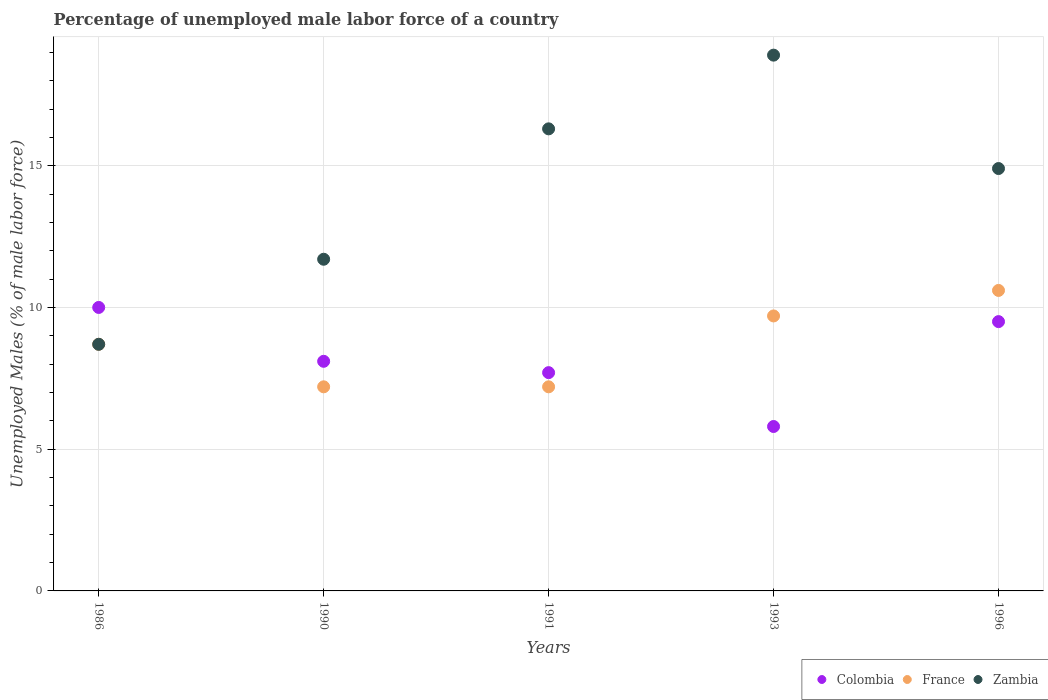Is the number of dotlines equal to the number of legend labels?
Your answer should be very brief. Yes. What is the percentage of unemployed male labor force in Zambia in 1991?
Make the answer very short. 16.3. Across all years, what is the maximum percentage of unemployed male labor force in France?
Give a very brief answer. 10.6. Across all years, what is the minimum percentage of unemployed male labor force in Colombia?
Your response must be concise. 5.8. In which year was the percentage of unemployed male labor force in Colombia maximum?
Keep it short and to the point. 1986. In which year was the percentage of unemployed male labor force in Zambia minimum?
Your answer should be very brief. 1986. What is the total percentage of unemployed male labor force in France in the graph?
Provide a short and direct response. 43.4. What is the difference between the percentage of unemployed male labor force in Zambia in 1990 and that in 1996?
Your answer should be compact. -3.2. What is the difference between the percentage of unemployed male labor force in Colombia in 1993 and the percentage of unemployed male labor force in Zambia in 1990?
Offer a terse response. -5.9. What is the average percentage of unemployed male labor force in Zambia per year?
Offer a terse response. 14.1. In the year 1993, what is the difference between the percentage of unemployed male labor force in France and percentage of unemployed male labor force in Zambia?
Your response must be concise. -9.2. What is the ratio of the percentage of unemployed male labor force in Colombia in 1993 to that in 1996?
Provide a succinct answer. 0.61. Is the percentage of unemployed male labor force in Zambia in 1986 less than that in 1990?
Offer a terse response. Yes. Is the difference between the percentage of unemployed male labor force in France in 1986 and 1991 greater than the difference between the percentage of unemployed male labor force in Zambia in 1986 and 1991?
Ensure brevity in your answer.  Yes. What is the difference between the highest and the second highest percentage of unemployed male labor force in Zambia?
Ensure brevity in your answer.  2.6. What is the difference between the highest and the lowest percentage of unemployed male labor force in Colombia?
Your answer should be very brief. 4.2. In how many years, is the percentage of unemployed male labor force in France greater than the average percentage of unemployed male labor force in France taken over all years?
Provide a short and direct response. 3. Is the sum of the percentage of unemployed male labor force in Colombia in 1986 and 1993 greater than the maximum percentage of unemployed male labor force in France across all years?
Your answer should be compact. Yes. Is the percentage of unemployed male labor force in France strictly greater than the percentage of unemployed male labor force in Zambia over the years?
Make the answer very short. No. Is the percentage of unemployed male labor force in France strictly less than the percentage of unemployed male labor force in Colombia over the years?
Make the answer very short. No. How many dotlines are there?
Give a very brief answer. 3. Are the values on the major ticks of Y-axis written in scientific E-notation?
Make the answer very short. No. Does the graph contain any zero values?
Your response must be concise. No. Where does the legend appear in the graph?
Provide a short and direct response. Bottom right. How are the legend labels stacked?
Provide a short and direct response. Horizontal. What is the title of the graph?
Give a very brief answer. Percentage of unemployed male labor force of a country. What is the label or title of the Y-axis?
Provide a short and direct response. Unemployed Males (% of male labor force). What is the Unemployed Males (% of male labor force) in Colombia in 1986?
Your answer should be compact. 10. What is the Unemployed Males (% of male labor force) in France in 1986?
Offer a very short reply. 8.7. What is the Unemployed Males (% of male labor force) in Zambia in 1986?
Offer a very short reply. 8.7. What is the Unemployed Males (% of male labor force) in Colombia in 1990?
Your answer should be compact. 8.1. What is the Unemployed Males (% of male labor force) in France in 1990?
Your answer should be compact. 7.2. What is the Unemployed Males (% of male labor force) in Zambia in 1990?
Your answer should be very brief. 11.7. What is the Unemployed Males (% of male labor force) of Colombia in 1991?
Ensure brevity in your answer.  7.7. What is the Unemployed Males (% of male labor force) of France in 1991?
Your answer should be very brief. 7.2. What is the Unemployed Males (% of male labor force) of Zambia in 1991?
Your answer should be compact. 16.3. What is the Unemployed Males (% of male labor force) in Colombia in 1993?
Keep it short and to the point. 5.8. What is the Unemployed Males (% of male labor force) of France in 1993?
Your response must be concise. 9.7. What is the Unemployed Males (% of male labor force) in Zambia in 1993?
Your answer should be compact. 18.9. What is the Unemployed Males (% of male labor force) of France in 1996?
Your response must be concise. 10.6. What is the Unemployed Males (% of male labor force) of Zambia in 1996?
Your answer should be very brief. 14.9. Across all years, what is the maximum Unemployed Males (% of male labor force) in Colombia?
Your answer should be compact. 10. Across all years, what is the maximum Unemployed Males (% of male labor force) in France?
Provide a short and direct response. 10.6. Across all years, what is the maximum Unemployed Males (% of male labor force) in Zambia?
Make the answer very short. 18.9. Across all years, what is the minimum Unemployed Males (% of male labor force) in Colombia?
Provide a short and direct response. 5.8. Across all years, what is the minimum Unemployed Males (% of male labor force) in France?
Your answer should be compact. 7.2. Across all years, what is the minimum Unemployed Males (% of male labor force) of Zambia?
Give a very brief answer. 8.7. What is the total Unemployed Males (% of male labor force) of Colombia in the graph?
Offer a terse response. 41.1. What is the total Unemployed Males (% of male labor force) of France in the graph?
Provide a succinct answer. 43.4. What is the total Unemployed Males (% of male labor force) in Zambia in the graph?
Ensure brevity in your answer.  70.5. What is the difference between the Unemployed Males (% of male labor force) of Zambia in 1986 and that in 1990?
Your answer should be compact. -3. What is the difference between the Unemployed Males (% of male labor force) in France in 1986 and that in 1991?
Ensure brevity in your answer.  1.5. What is the difference between the Unemployed Males (% of male labor force) in Colombia in 1986 and that in 1993?
Your answer should be compact. 4.2. What is the difference between the Unemployed Males (% of male labor force) of France in 1986 and that in 1993?
Keep it short and to the point. -1. What is the difference between the Unemployed Males (% of male labor force) in Colombia in 1986 and that in 1996?
Ensure brevity in your answer.  0.5. What is the difference between the Unemployed Males (% of male labor force) in Zambia in 1986 and that in 1996?
Ensure brevity in your answer.  -6.2. What is the difference between the Unemployed Males (% of male labor force) of Colombia in 1990 and that in 1991?
Provide a short and direct response. 0.4. What is the difference between the Unemployed Males (% of male labor force) of Zambia in 1990 and that in 1991?
Your answer should be compact. -4.6. What is the difference between the Unemployed Males (% of male labor force) in Zambia in 1990 and that in 1993?
Make the answer very short. -7.2. What is the difference between the Unemployed Males (% of male labor force) of France in 1990 and that in 1996?
Provide a succinct answer. -3.4. What is the difference between the Unemployed Males (% of male labor force) in Zambia in 1990 and that in 1996?
Offer a terse response. -3.2. What is the difference between the Unemployed Males (% of male labor force) in Colombia in 1991 and that in 1993?
Offer a very short reply. 1.9. What is the difference between the Unemployed Males (% of male labor force) of Colombia in 1991 and that in 1996?
Make the answer very short. -1.8. What is the difference between the Unemployed Males (% of male labor force) of France in 1991 and that in 1996?
Keep it short and to the point. -3.4. What is the difference between the Unemployed Males (% of male labor force) in Zambia in 1991 and that in 1996?
Offer a very short reply. 1.4. What is the difference between the Unemployed Males (% of male labor force) in France in 1993 and that in 1996?
Keep it short and to the point. -0.9. What is the difference between the Unemployed Males (% of male labor force) in Zambia in 1993 and that in 1996?
Provide a short and direct response. 4. What is the difference between the Unemployed Males (% of male labor force) in Colombia in 1986 and the Unemployed Males (% of male labor force) in France in 1990?
Provide a succinct answer. 2.8. What is the difference between the Unemployed Males (% of male labor force) of France in 1986 and the Unemployed Males (% of male labor force) of Zambia in 1990?
Your response must be concise. -3. What is the difference between the Unemployed Males (% of male labor force) in Colombia in 1986 and the Unemployed Males (% of male labor force) in France in 1991?
Your response must be concise. 2.8. What is the difference between the Unemployed Males (% of male labor force) of France in 1986 and the Unemployed Males (% of male labor force) of Zambia in 1991?
Provide a succinct answer. -7.6. What is the difference between the Unemployed Males (% of male labor force) in Colombia in 1986 and the Unemployed Males (% of male labor force) in France in 1993?
Provide a short and direct response. 0.3. What is the difference between the Unemployed Males (% of male labor force) of Colombia in 1986 and the Unemployed Males (% of male labor force) of Zambia in 1993?
Keep it short and to the point. -8.9. What is the difference between the Unemployed Males (% of male labor force) of France in 1986 and the Unemployed Males (% of male labor force) of Zambia in 1993?
Ensure brevity in your answer.  -10.2. What is the difference between the Unemployed Males (% of male labor force) of Colombia in 1986 and the Unemployed Males (% of male labor force) of France in 1996?
Provide a succinct answer. -0.6. What is the difference between the Unemployed Males (% of male labor force) in Colombia in 1990 and the Unemployed Males (% of male labor force) in Zambia in 1991?
Provide a short and direct response. -8.2. What is the difference between the Unemployed Males (% of male labor force) in France in 1990 and the Unemployed Males (% of male labor force) in Zambia in 1991?
Ensure brevity in your answer.  -9.1. What is the difference between the Unemployed Males (% of male labor force) in Colombia in 1990 and the Unemployed Males (% of male labor force) in France in 1993?
Provide a short and direct response. -1.6. What is the difference between the Unemployed Males (% of male labor force) of Colombia in 1990 and the Unemployed Males (% of male labor force) of Zambia in 1993?
Keep it short and to the point. -10.8. What is the difference between the Unemployed Males (% of male labor force) of France in 1990 and the Unemployed Males (% of male labor force) of Zambia in 1993?
Your answer should be very brief. -11.7. What is the difference between the Unemployed Males (% of male labor force) of Colombia in 1990 and the Unemployed Males (% of male labor force) of France in 1996?
Offer a terse response. -2.5. What is the difference between the Unemployed Males (% of male labor force) of France in 1990 and the Unemployed Males (% of male labor force) of Zambia in 1996?
Your answer should be compact. -7.7. What is the difference between the Unemployed Males (% of male labor force) in Colombia in 1991 and the Unemployed Males (% of male labor force) in France in 1993?
Your answer should be very brief. -2. What is the difference between the Unemployed Males (% of male labor force) in Colombia in 1991 and the Unemployed Males (% of male labor force) in Zambia in 1993?
Keep it short and to the point. -11.2. What is the difference between the Unemployed Males (% of male labor force) in France in 1991 and the Unemployed Males (% of male labor force) in Zambia in 1993?
Make the answer very short. -11.7. What is the difference between the Unemployed Males (% of male labor force) in Colombia in 1991 and the Unemployed Males (% of male labor force) in Zambia in 1996?
Your answer should be very brief. -7.2. What is the difference between the Unemployed Males (% of male labor force) in Colombia in 1993 and the Unemployed Males (% of male labor force) in France in 1996?
Your response must be concise. -4.8. What is the average Unemployed Males (% of male labor force) of Colombia per year?
Offer a terse response. 8.22. What is the average Unemployed Males (% of male labor force) in France per year?
Keep it short and to the point. 8.68. In the year 1990, what is the difference between the Unemployed Males (% of male labor force) in Colombia and Unemployed Males (% of male labor force) in France?
Offer a terse response. 0.9. In the year 1991, what is the difference between the Unemployed Males (% of male labor force) of Colombia and Unemployed Males (% of male labor force) of Zambia?
Provide a short and direct response. -8.6. In the year 1993, what is the difference between the Unemployed Males (% of male labor force) in Colombia and Unemployed Males (% of male labor force) in Zambia?
Give a very brief answer. -13.1. In the year 1996, what is the difference between the Unemployed Males (% of male labor force) in Colombia and Unemployed Males (% of male labor force) in Zambia?
Offer a very short reply. -5.4. In the year 1996, what is the difference between the Unemployed Males (% of male labor force) in France and Unemployed Males (% of male labor force) in Zambia?
Provide a short and direct response. -4.3. What is the ratio of the Unemployed Males (% of male labor force) of Colombia in 1986 to that in 1990?
Ensure brevity in your answer.  1.23. What is the ratio of the Unemployed Males (% of male labor force) in France in 1986 to that in 1990?
Provide a short and direct response. 1.21. What is the ratio of the Unemployed Males (% of male labor force) of Zambia in 1986 to that in 1990?
Keep it short and to the point. 0.74. What is the ratio of the Unemployed Males (% of male labor force) of Colombia in 1986 to that in 1991?
Keep it short and to the point. 1.3. What is the ratio of the Unemployed Males (% of male labor force) in France in 1986 to that in 1991?
Provide a short and direct response. 1.21. What is the ratio of the Unemployed Males (% of male labor force) of Zambia in 1986 to that in 1991?
Offer a terse response. 0.53. What is the ratio of the Unemployed Males (% of male labor force) of Colombia in 1986 to that in 1993?
Provide a short and direct response. 1.72. What is the ratio of the Unemployed Males (% of male labor force) in France in 1986 to that in 1993?
Ensure brevity in your answer.  0.9. What is the ratio of the Unemployed Males (% of male labor force) of Zambia in 1986 to that in 1993?
Give a very brief answer. 0.46. What is the ratio of the Unemployed Males (% of male labor force) of Colombia in 1986 to that in 1996?
Offer a terse response. 1.05. What is the ratio of the Unemployed Males (% of male labor force) of France in 1986 to that in 1996?
Make the answer very short. 0.82. What is the ratio of the Unemployed Males (% of male labor force) in Zambia in 1986 to that in 1996?
Offer a terse response. 0.58. What is the ratio of the Unemployed Males (% of male labor force) of Colombia in 1990 to that in 1991?
Your answer should be very brief. 1.05. What is the ratio of the Unemployed Males (% of male labor force) in Zambia in 1990 to that in 1991?
Offer a very short reply. 0.72. What is the ratio of the Unemployed Males (% of male labor force) of Colombia in 1990 to that in 1993?
Make the answer very short. 1.4. What is the ratio of the Unemployed Males (% of male labor force) in France in 1990 to that in 1993?
Give a very brief answer. 0.74. What is the ratio of the Unemployed Males (% of male labor force) of Zambia in 1990 to that in 1993?
Make the answer very short. 0.62. What is the ratio of the Unemployed Males (% of male labor force) in Colombia in 1990 to that in 1996?
Your answer should be very brief. 0.85. What is the ratio of the Unemployed Males (% of male labor force) in France in 1990 to that in 1996?
Your response must be concise. 0.68. What is the ratio of the Unemployed Males (% of male labor force) in Zambia in 1990 to that in 1996?
Ensure brevity in your answer.  0.79. What is the ratio of the Unemployed Males (% of male labor force) in Colombia in 1991 to that in 1993?
Make the answer very short. 1.33. What is the ratio of the Unemployed Males (% of male labor force) in France in 1991 to that in 1993?
Your answer should be compact. 0.74. What is the ratio of the Unemployed Males (% of male labor force) in Zambia in 1991 to that in 1993?
Offer a very short reply. 0.86. What is the ratio of the Unemployed Males (% of male labor force) of Colombia in 1991 to that in 1996?
Your answer should be compact. 0.81. What is the ratio of the Unemployed Males (% of male labor force) in France in 1991 to that in 1996?
Provide a succinct answer. 0.68. What is the ratio of the Unemployed Males (% of male labor force) in Zambia in 1991 to that in 1996?
Provide a short and direct response. 1.09. What is the ratio of the Unemployed Males (% of male labor force) in Colombia in 1993 to that in 1996?
Your answer should be very brief. 0.61. What is the ratio of the Unemployed Males (% of male labor force) of France in 1993 to that in 1996?
Offer a terse response. 0.92. What is the ratio of the Unemployed Males (% of male labor force) in Zambia in 1993 to that in 1996?
Keep it short and to the point. 1.27. What is the difference between the highest and the second highest Unemployed Males (% of male labor force) of Colombia?
Make the answer very short. 0.5. What is the difference between the highest and the second highest Unemployed Males (% of male labor force) in France?
Your answer should be compact. 0.9. What is the difference between the highest and the second highest Unemployed Males (% of male labor force) in Zambia?
Ensure brevity in your answer.  2.6. What is the difference between the highest and the lowest Unemployed Males (% of male labor force) in France?
Your answer should be very brief. 3.4. What is the difference between the highest and the lowest Unemployed Males (% of male labor force) in Zambia?
Provide a succinct answer. 10.2. 